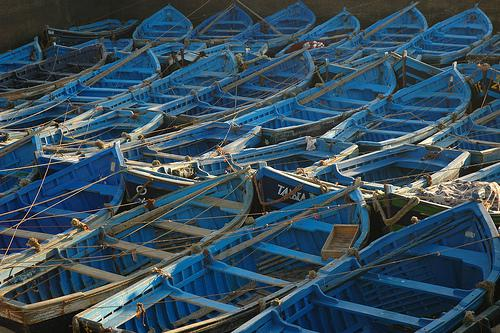Question: what is this picture of?
Choices:
A. Cars.
B. A train.
C. Boats.
D. Airplanes.
Answer with the letter. Answer: C Question: how many boats are in the image?
Choices:
A. Twenty.
B. Twenty-one.
C. Twenty-Six.
D. Twenty-seven.
Answer with the letter. Answer: C Question: how many center planks does each boat have?
Choices:
A. Two.
B. Four.
C. Three.
D. Five.
Answer with the letter. Answer: B 